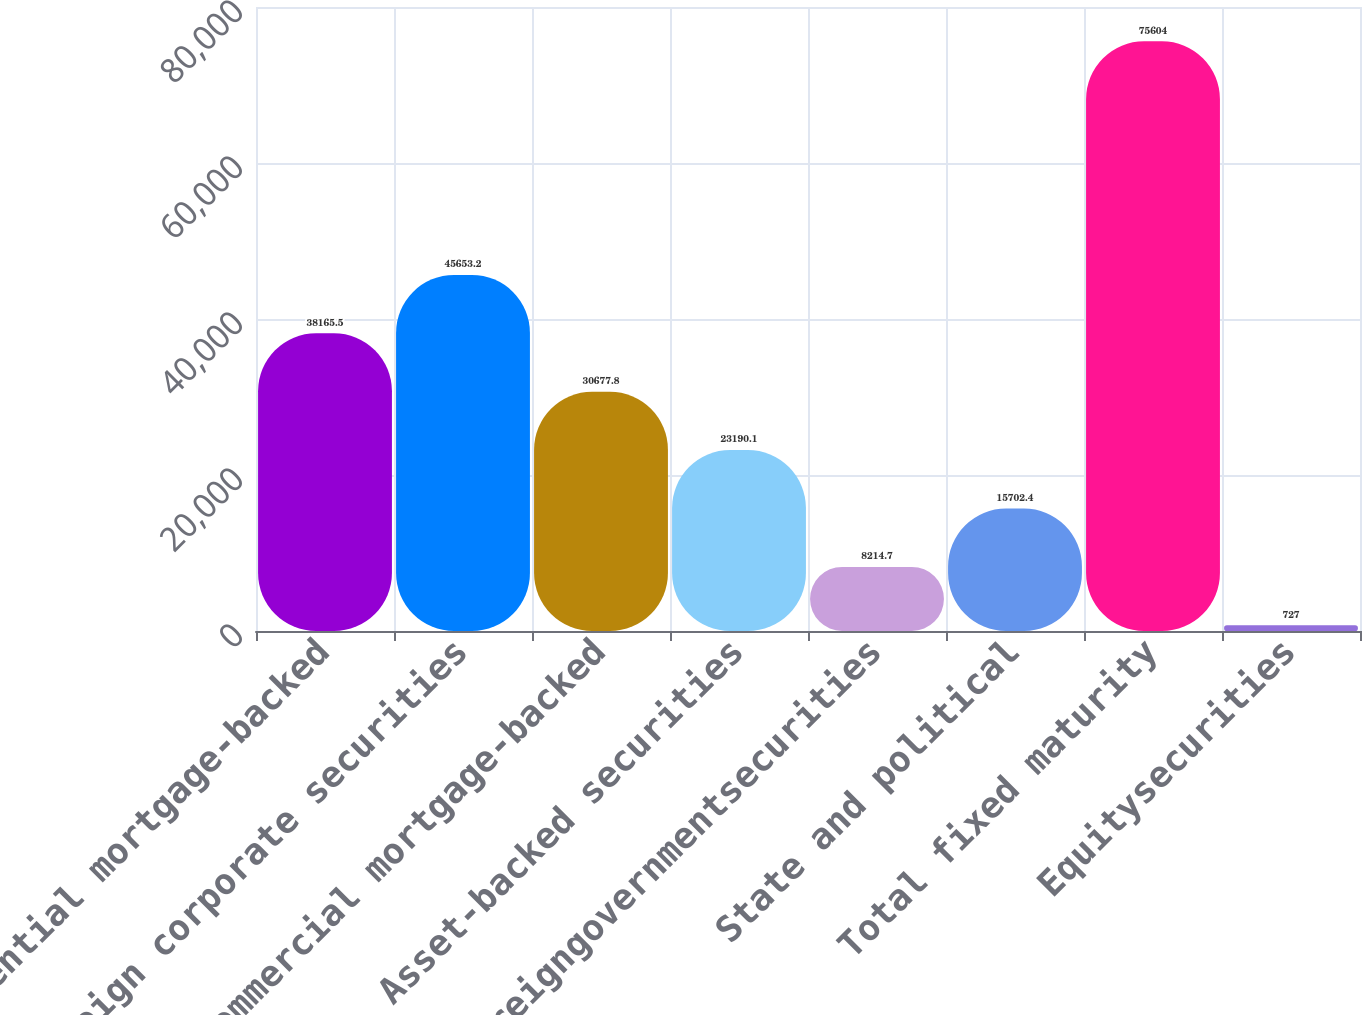Convert chart to OTSL. <chart><loc_0><loc_0><loc_500><loc_500><bar_chart><fcel>Residential mortgage-backed<fcel>Foreign corporate securities<fcel>Commercial mortgage-backed<fcel>Asset-backed securities<fcel>Foreigngovernmentsecurities<fcel>State and political<fcel>Total fixed maturity<fcel>Equitysecurities<nl><fcel>38165.5<fcel>45653.2<fcel>30677.8<fcel>23190.1<fcel>8214.7<fcel>15702.4<fcel>75604<fcel>727<nl></chart> 